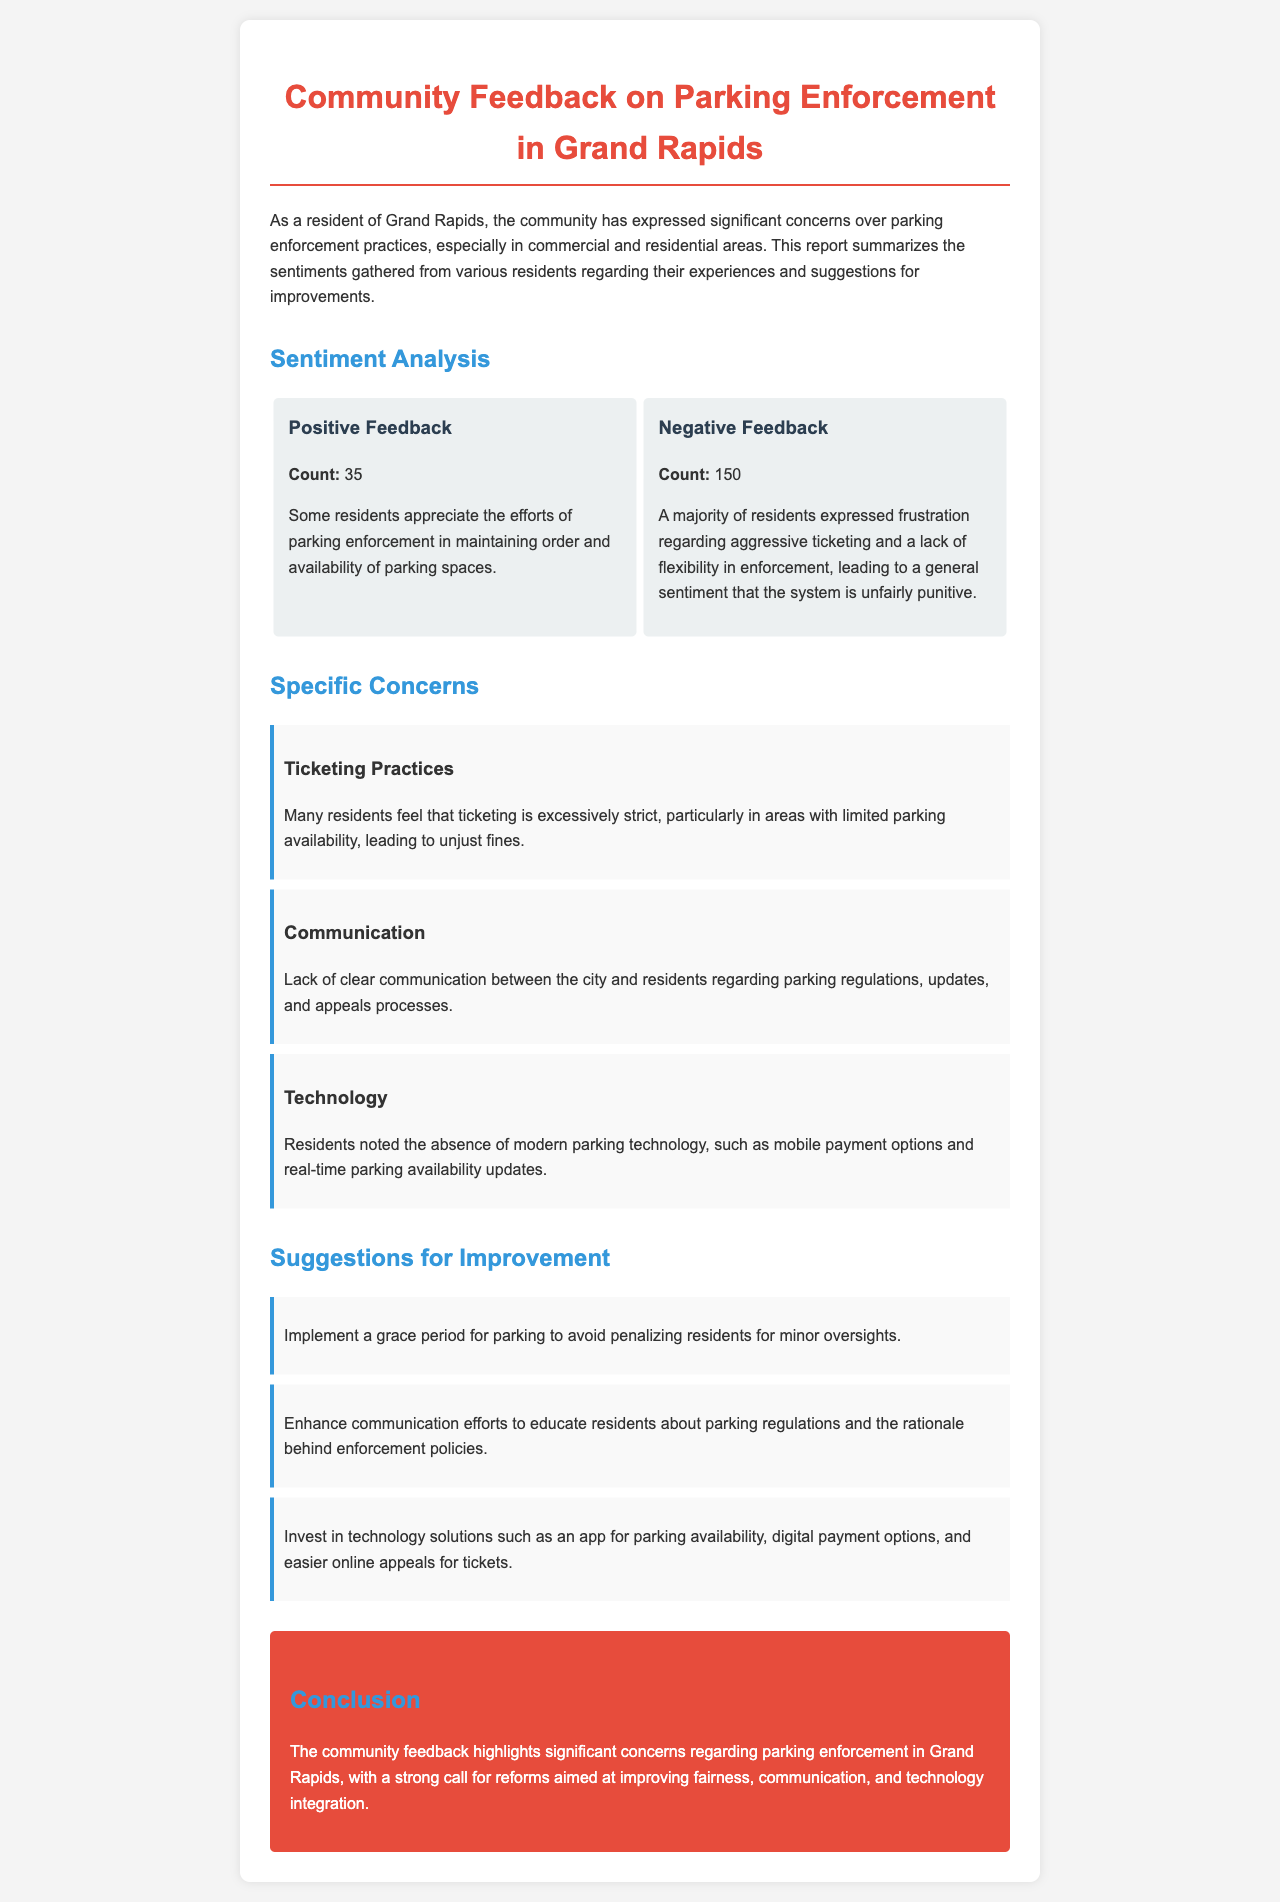What is the title of the report? The title of the report is presented prominently at the top of the document.
Answer: Community Feedback on Parking Enforcement in Grand Rapids How many residents expressed positive feedback? The document contains a count of positive feedback, outlined in the sentiment analysis section.
Answer: 35 What is the primary concern regarding ticketing practices? The specific concerns section highlights the key issues residents have with ticketing practices.
Answer: Excessively strict What technology solutions are suggested? The suggestions for improvement focus on the type of technology that residents believe should be invested in.
Answer: Mobile payment options What is the total count of negative feedback? This count is also provided in the sentiment analysis section, illustrating the negative sentiment among residents.
Answer: 150 What do residents want regarding communication? The specific concerns mention the gap that exists in communication between the city and residents.
Answer: Clear communication What is one proposed improvement for parking enforcement? Suggestions for improvement detail what changes residents are advocating for to make parking enforcement fairer.
Answer: Grace period What is the document's conclusion focused on? The conclusion summarises the overall sentiment and key themes of the feedback collected from residents.
Answer: Reforms aimed at improving fairness, communication, and technology integration What is the dominant sentiment expressed by the community? The document categorizes the responses into positive and negative feedback, indicating the overall sentiment.
Answer: Frustration 